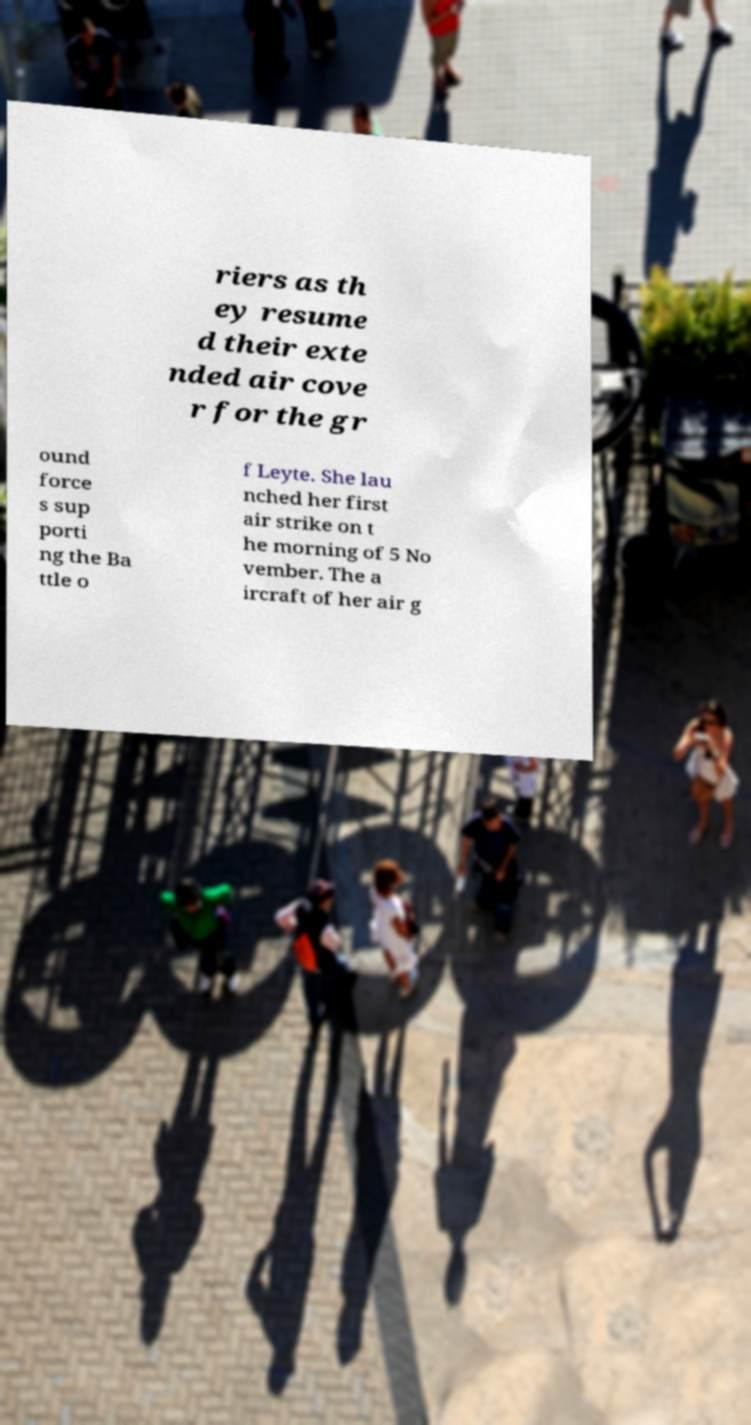Can you read and provide the text displayed in the image?This photo seems to have some interesting text. Can you extract and type it out for me? riers as th ey resume d their exte nded air cove r for the gr ound force s sup porti ng the Ba ttle o f Leyte. She lau nched her first air strike on t he morning of 5 No vember. The a ircraft of her air g 